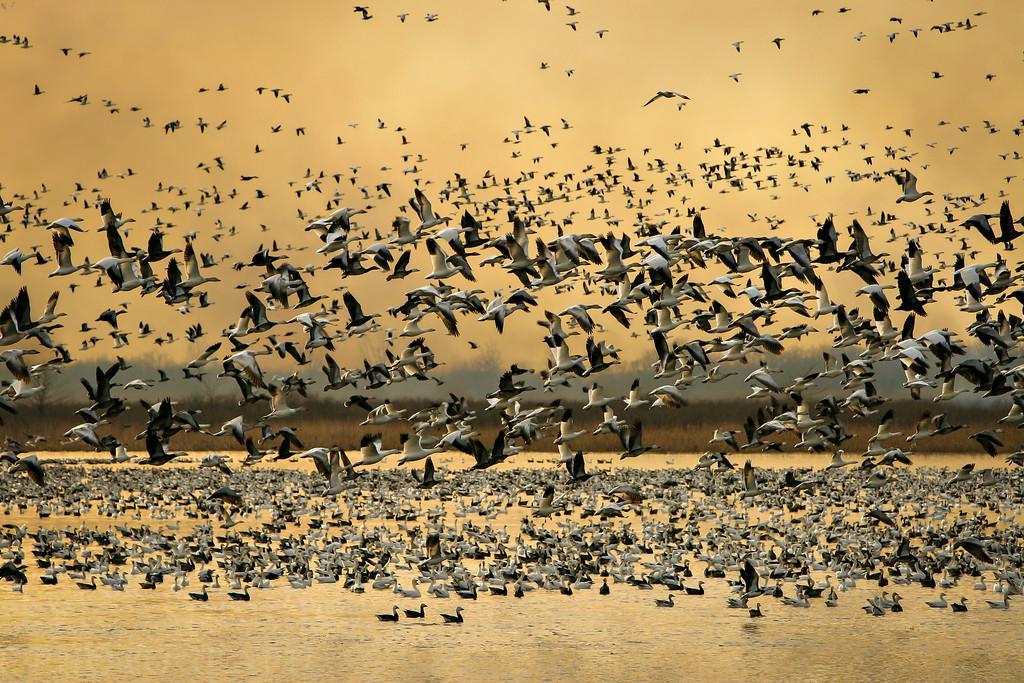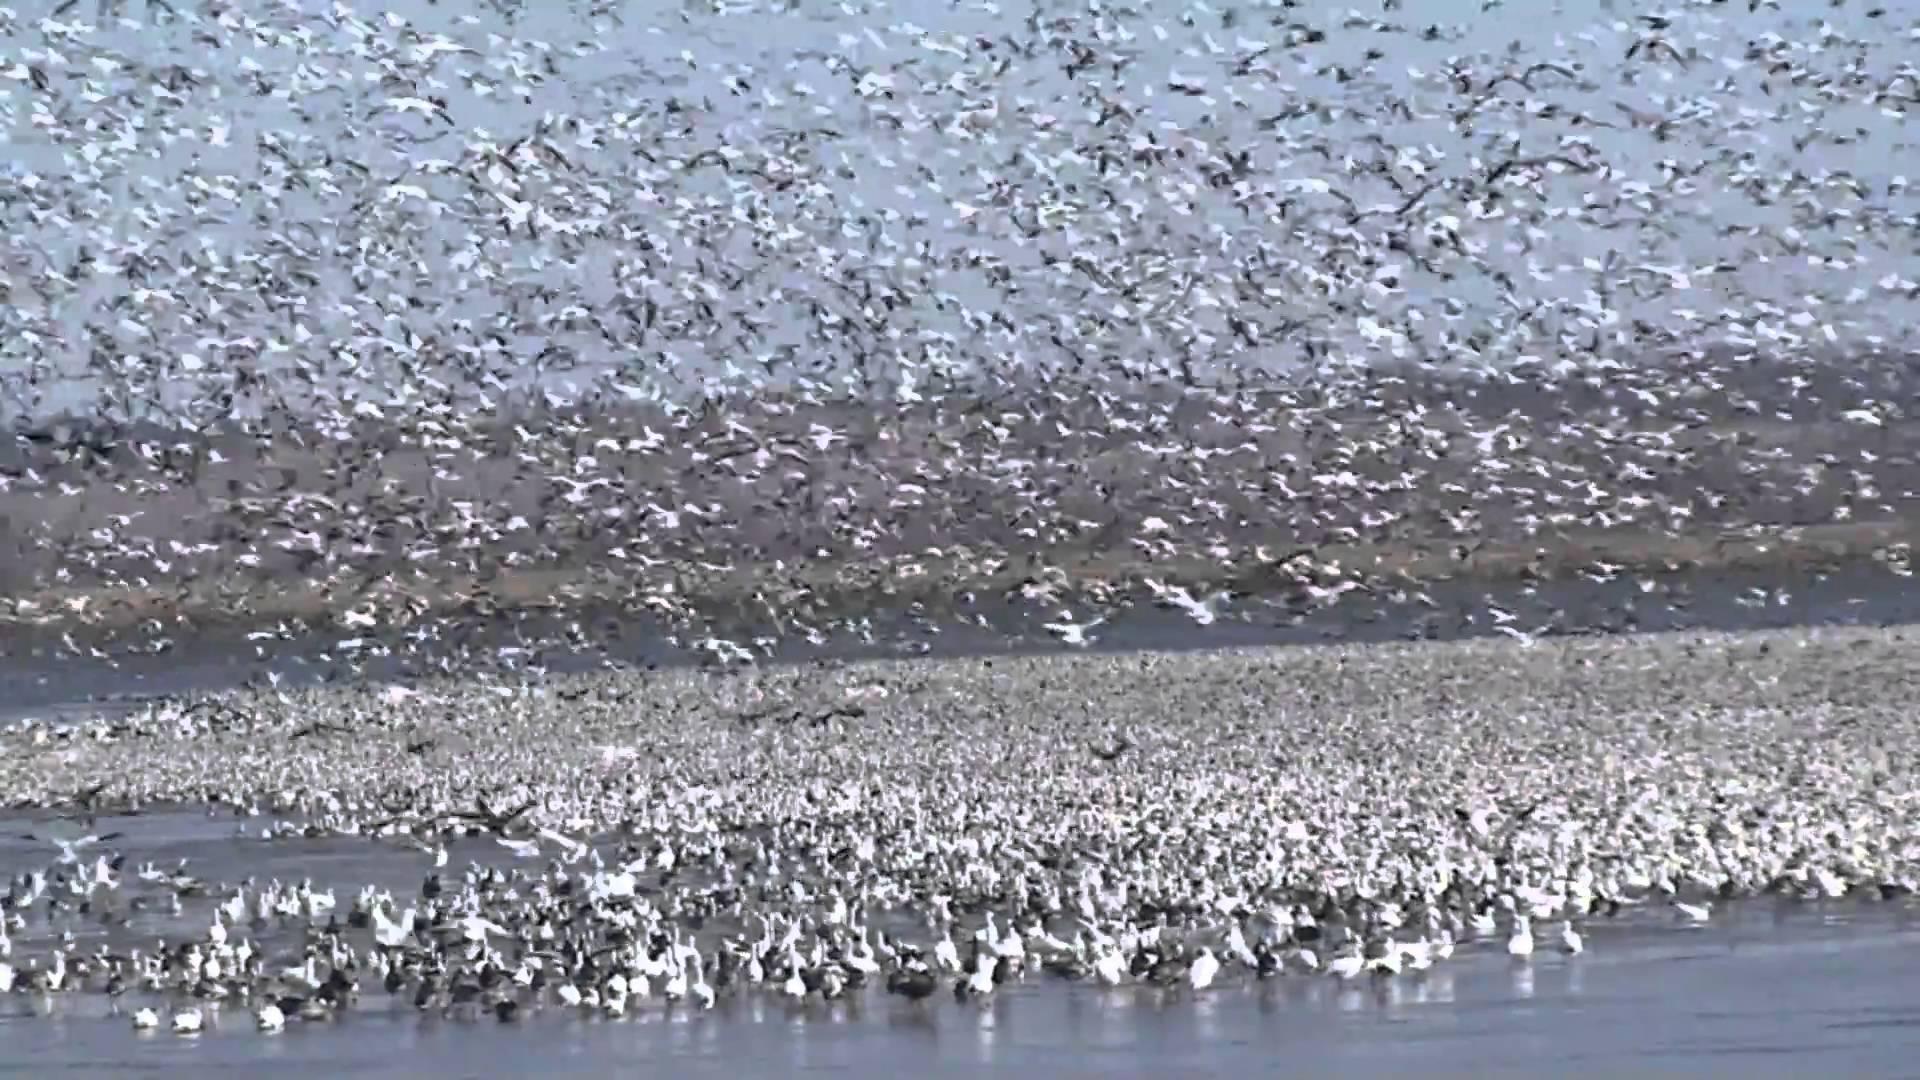The first image is the image on the left, the second image is the image on the right. Evaluate the accuracy of this statement regarding the images: "There are several birds swimming in the water near the bottom on the image on the left.". Is it true? Answer yes or no. Yes. 